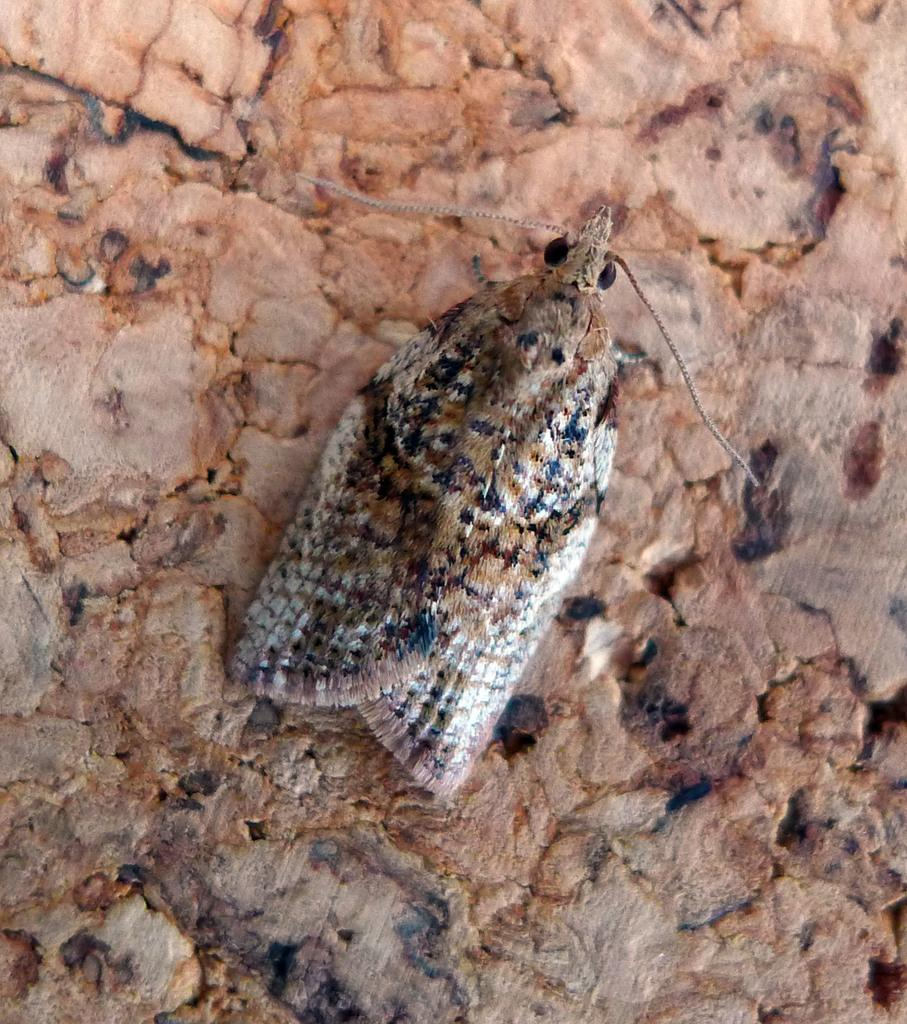What type of creature is present in the image? There is an insect in the image. What is the insect sitting on in the image? The insect is on some object. Where is the insect and the object located in the image? The insect and the object are in the center of the image. What is the name of the vase that the insect is sitting on in the image? There is no vase present in the image; the insect is on some object. What type of loss is depicted in the image? There is no loss depicted in the image; it features an insect on an object. 